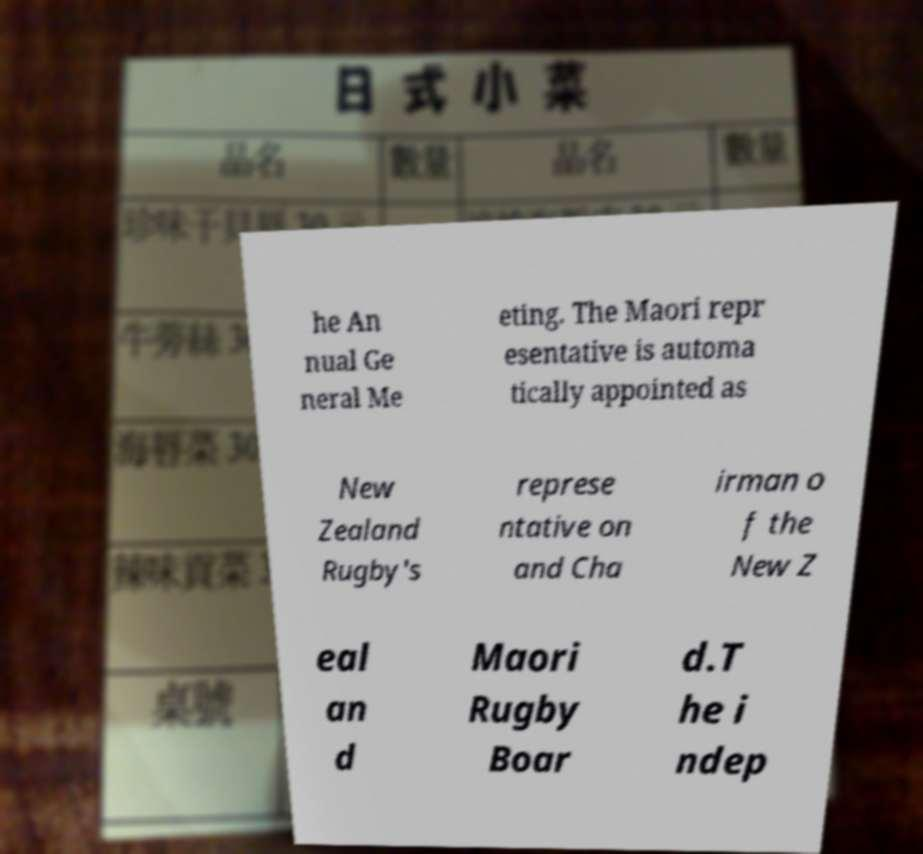Could you assist in decoding the text presented in this image and type it out clearly? he An nual Ge neral Me eting. The Maori repr esentative is automa tically appointed as New Zealand Rugby's represe ntative on and Cha irman o f the New Z eal an d Maori Rugby Boar d.T he i ndep 